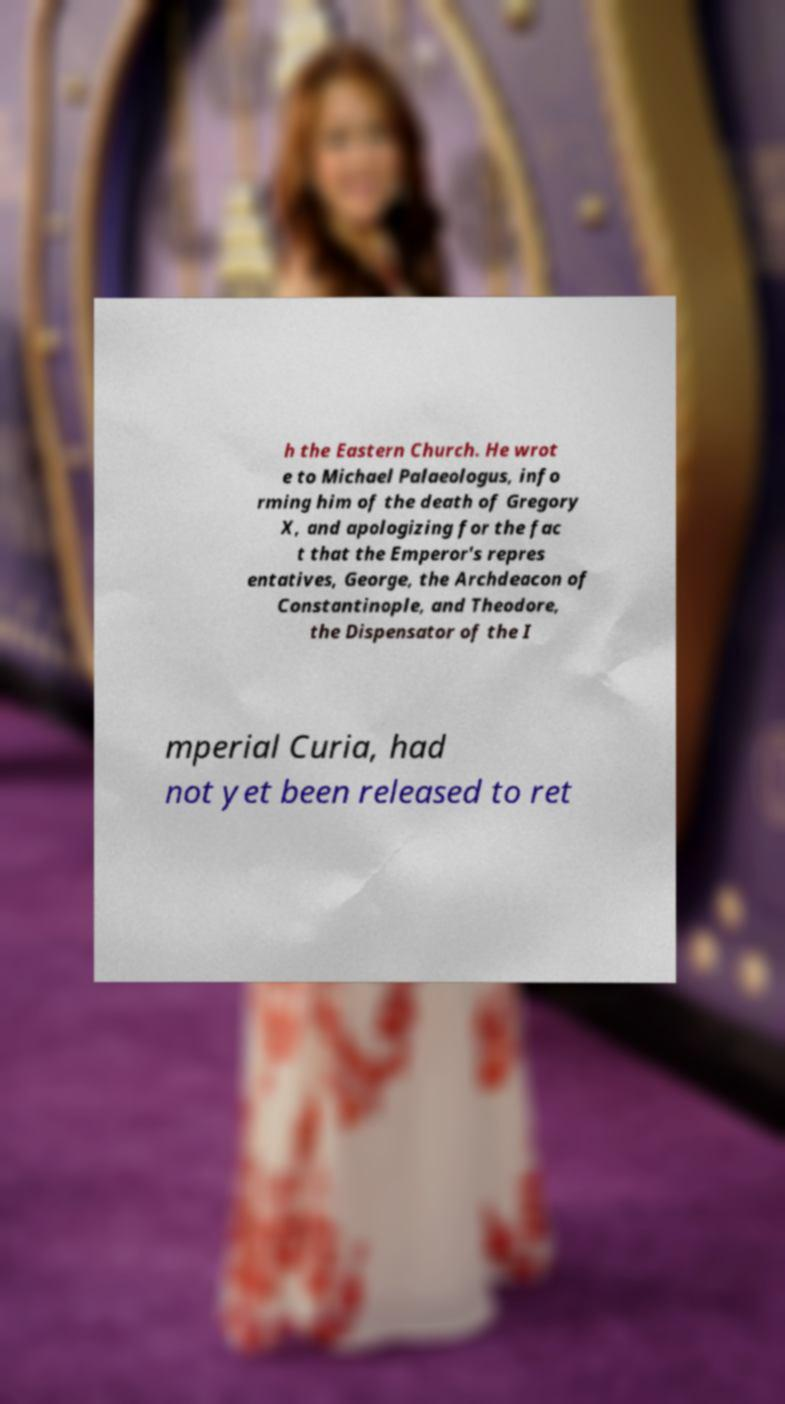Could you assist in decoding the text presented in this image and type it out clearly? h the Eastern Church. He wrot e to Michael Palaeologus, info rming him of the death of Gregory X, and apologizing for the fac t that the Emperor's repres entatives, George, the Archdeacon of Constantinople, and Theodore, the Dispensator of the I mperial Curia, had not yet been released to ret 